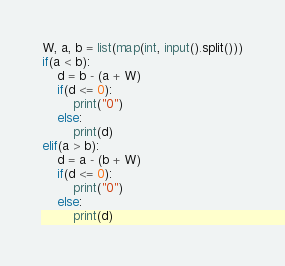Convert code to text. <code><loc_0><loc_0><loc_500><loc_500><_Python_>W, a, b = list(map(int, input().split()))
if(a < b):
    d = b - (a + W)
    if(d <= 0):
        print("0")
    else:
        print(d)
elif(a > b):
    d = a - (b + W)
    if(d <= 0):
        print("0")
    else:
        print(d)
</code> 